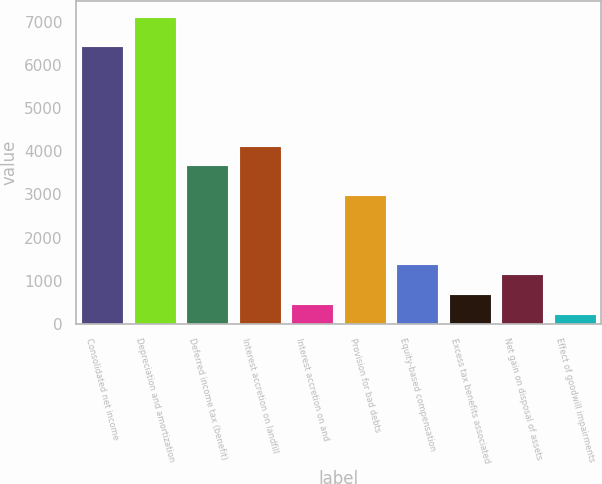Convert chart. <chart><loc_0><loc_0><loc_500><loc_500><bar_chart><fcel>Consolidated net income<fcel>Depreciation and amortization<fcel>Deferred income tax (benefit)<fcel>Interest accretion on landfill<fcel>Interest accretion on and<fcel>Provision for bad debts<fcel>Equity-based compensation<fcel>Excess tax benefits associated<fcel>Net gain on disposal of assets<fcel>Effect of goodwill impairments<nl><fcel>6424.2<fcel>7112.4<fcel>3671.4<fcel>4130.2<fcel>459.8<fcel>2983.2<fcel>1377.4<fcel>689.2<fcel>1148<fcel>230.4<nl></chart> 